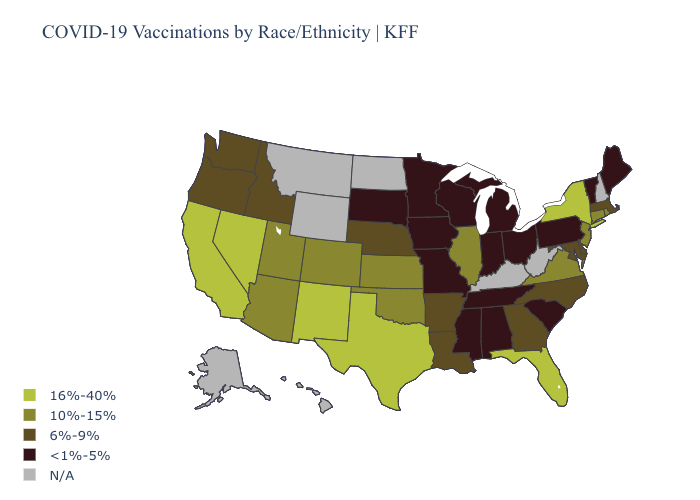Among the states that border Kansas , which have the highest value?
Be succinct. Colorado, Oklahoma. Which states have the lowest value in the Northeast?
Quick response, please. Maine, Pennsylvania, Vermont. Does Colorado have the lowest value in the USA?
Give a very brief answer. No. Which states have the lowest value in the MidWest?
Give a very brief answer. Indiana, Iowa, Michigan, Minnesota, Missouri, Ohio, South Dakota, Wisconsin. Name the states that have a value in the range <1%-5%?
Be succinct. Alabama, Indiana, Iowa, Maine, Michigan, Minnesota, Mississippi, Missouri, Ohio, Pennsylvania, South Carolina, South Dakota, Tennessee, Vermont, Wisconsin. Does the first symbol in the legend represent the smallest category?
Short answer required. No. Is the legend a continuous bar?
Concise answer only. No. Does Florida have the highest value in the USA?
Be succinct. Yes. What is the highest value in the South ?
Answer briefly. 16%-40%. Which states hav the highest value in the Northeast?
Short answer required. New York. What is the highest value in the MidWest ?
Keep it brief. 10%-15%. Among the states that border Utah , which have the highest value?
Keep it brief. Nevada, New Mexico. 